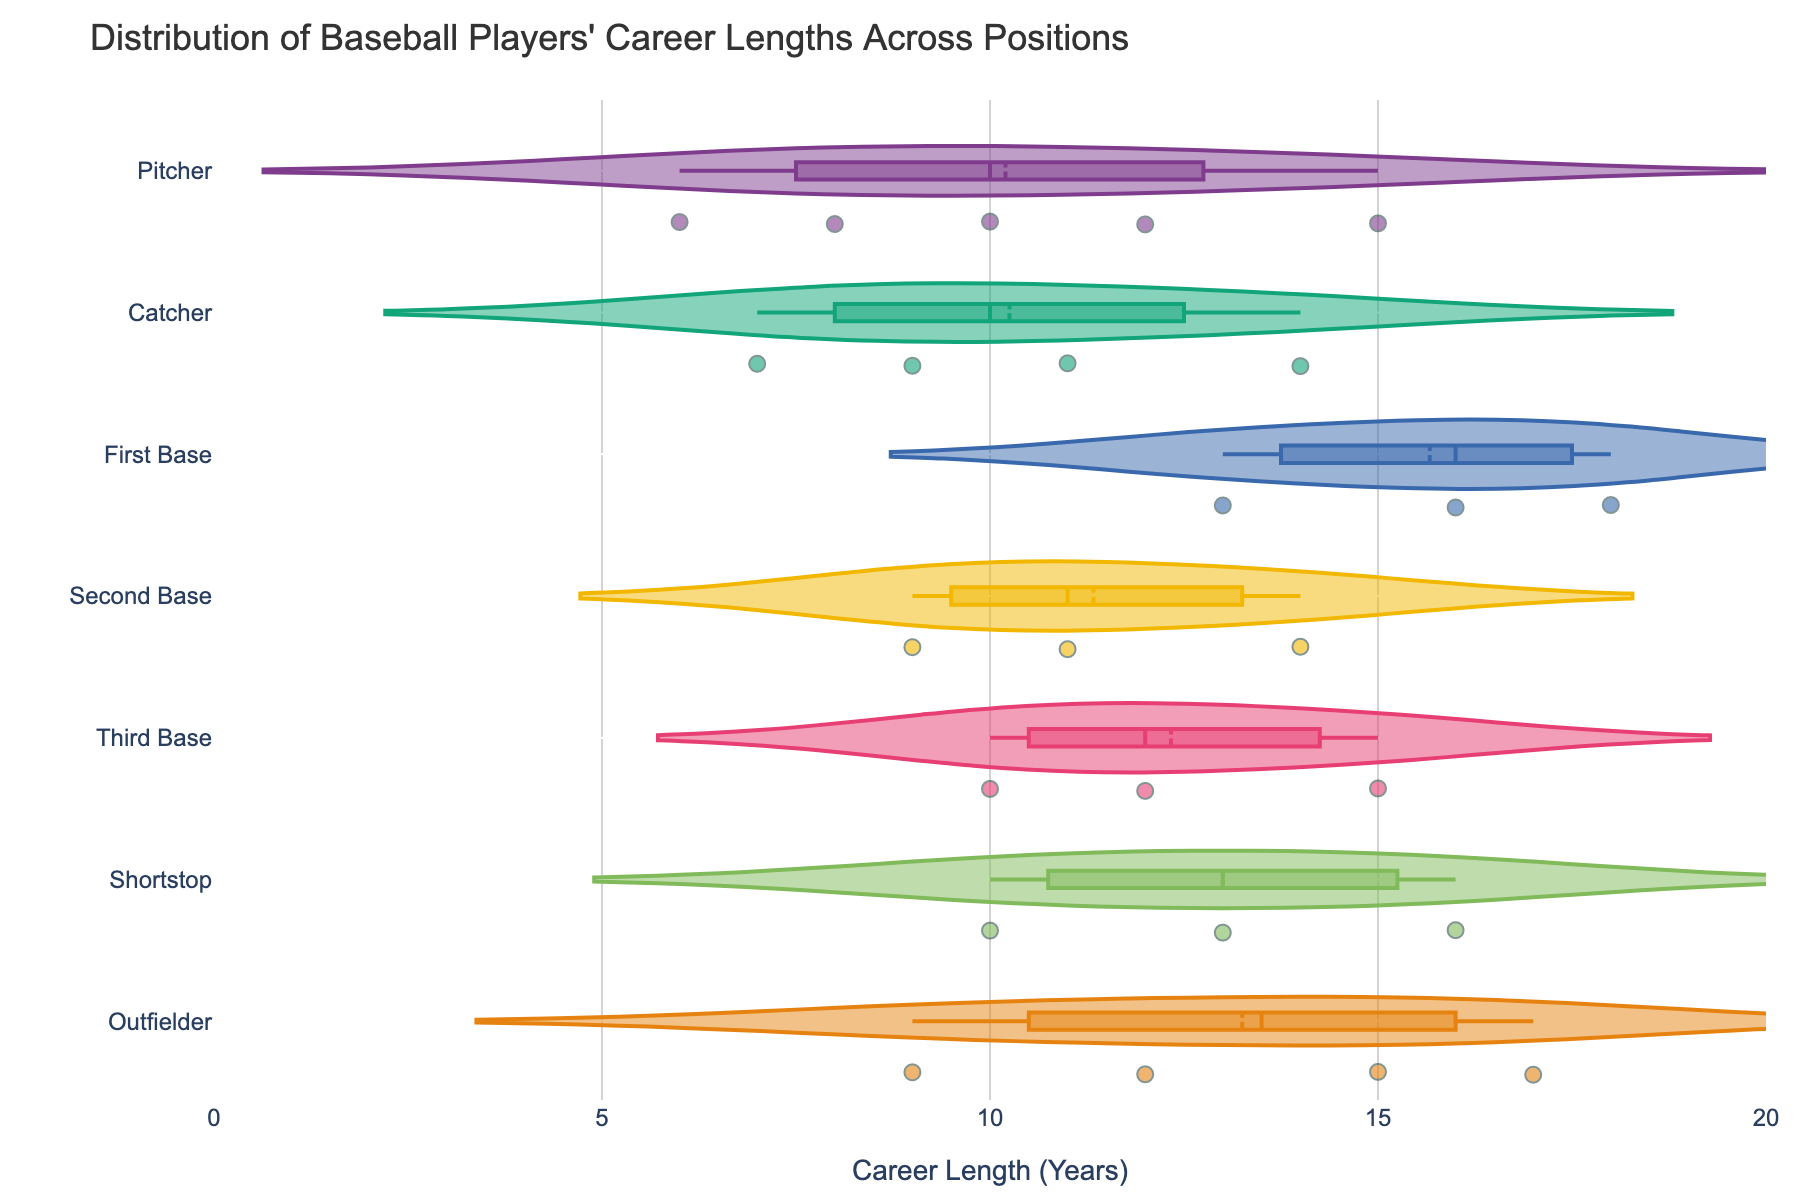what is the title of the plot? The title can be found at the top of the figure. It helps to quickly understand what the plot is about.
Answer: Distribution of Baseball Players' Career Lengths Across Positions Which position has the highest mean career length? Check the dot at the meanline visible for each position and find the one that is the furthest to the right.
Answer: First Base How many positions are displayed in the figure? Count the number of different categories listed along the y-axis.
Answer: 6 Which position has the widest distribution of career lengths? Look for the position with the largest spread (long horizontal line) in its violin plot.
Answer: Pitcher What is the shortest career length observed for Outfielders? Look at the leftmost point of the Outfielder's violin plot.
Answer: 9 years Which position has the most consistent career length, judging by the box width? Look for the position with the narrowest box plot within the violin plot.
Answer: Catcher Compare the median career length of Second Base and Shortstop players. Which is higher? Identify the middle line within the boxes of the Second Base and Shortstop violin plots and compare them.
Answer: Shortstop What is the interquartile range (IQR) for the Pitchers? Look at the box plot within the Pitcher violin to find the upper and lower bounds of the box, then calculate their difference.
Answer: 4 years (Note: Requires identifying the bounds from the figure.) Which two positions have the closest median career lengths? Compare the middle lines within the boxes for each position to find the two that are closest.
Answer: Third Base and Shortstop Are there more Pitchers or Outfielders in the data? Count the number of individual points (data points) within the Pitcher and Outfielder violin plots.
Answer: Outfielders 